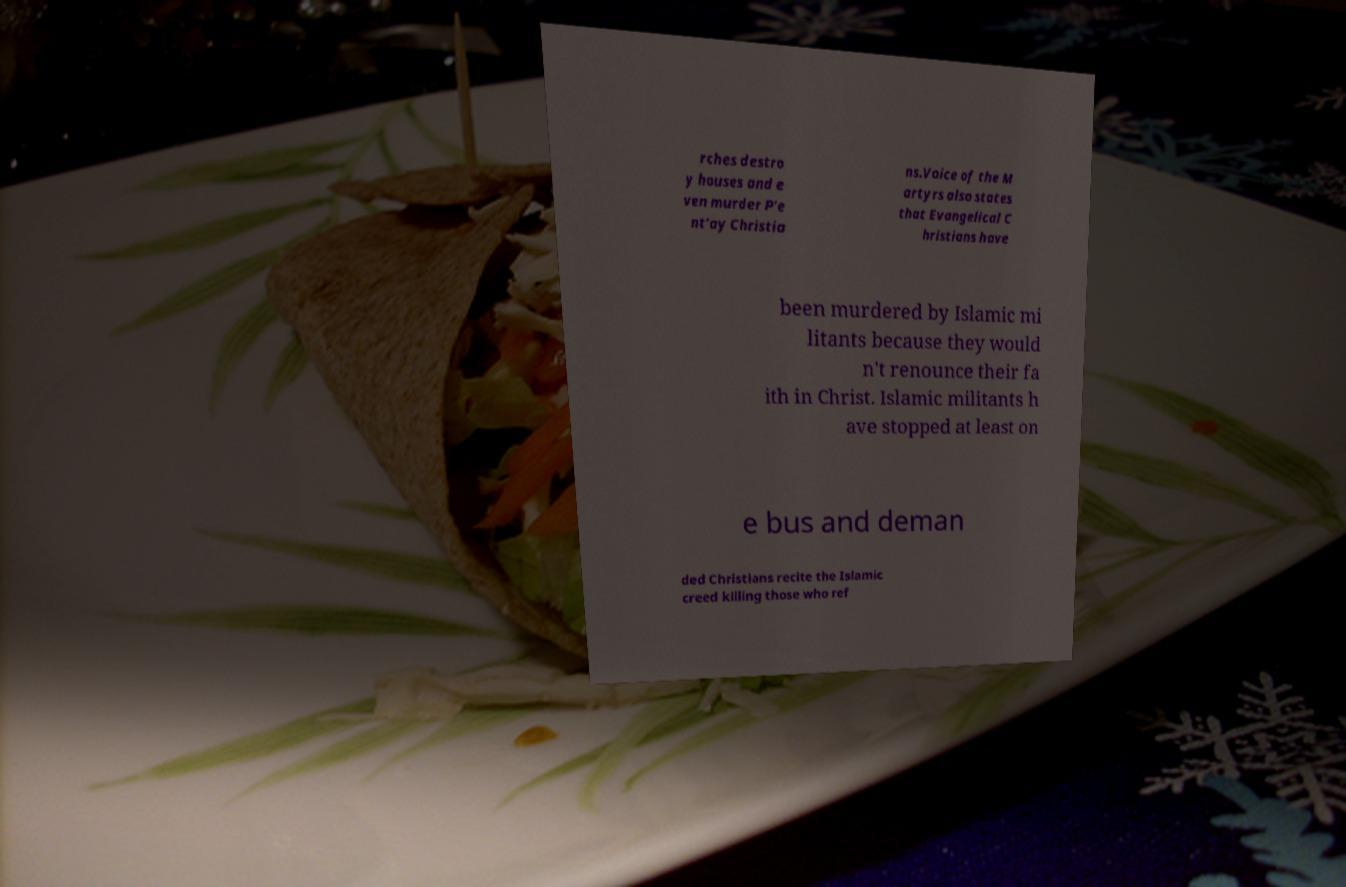I need the written content from this picture converted into text. Can you do that? rches destro y houses and e ven murder P'e nt'ay Christia ns.Voice of the M artyrs also states that Evangelical C hristians have been murdered by Islamic mi litants because they would n't renounce their fa ith in Christ. Islamic militants h ave stopped at least on e bus and deman ded Christians recite the Islamic creed killing those who ref 